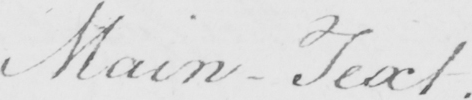Transcribe the text shown in this historical manuscript line. Main-Text 